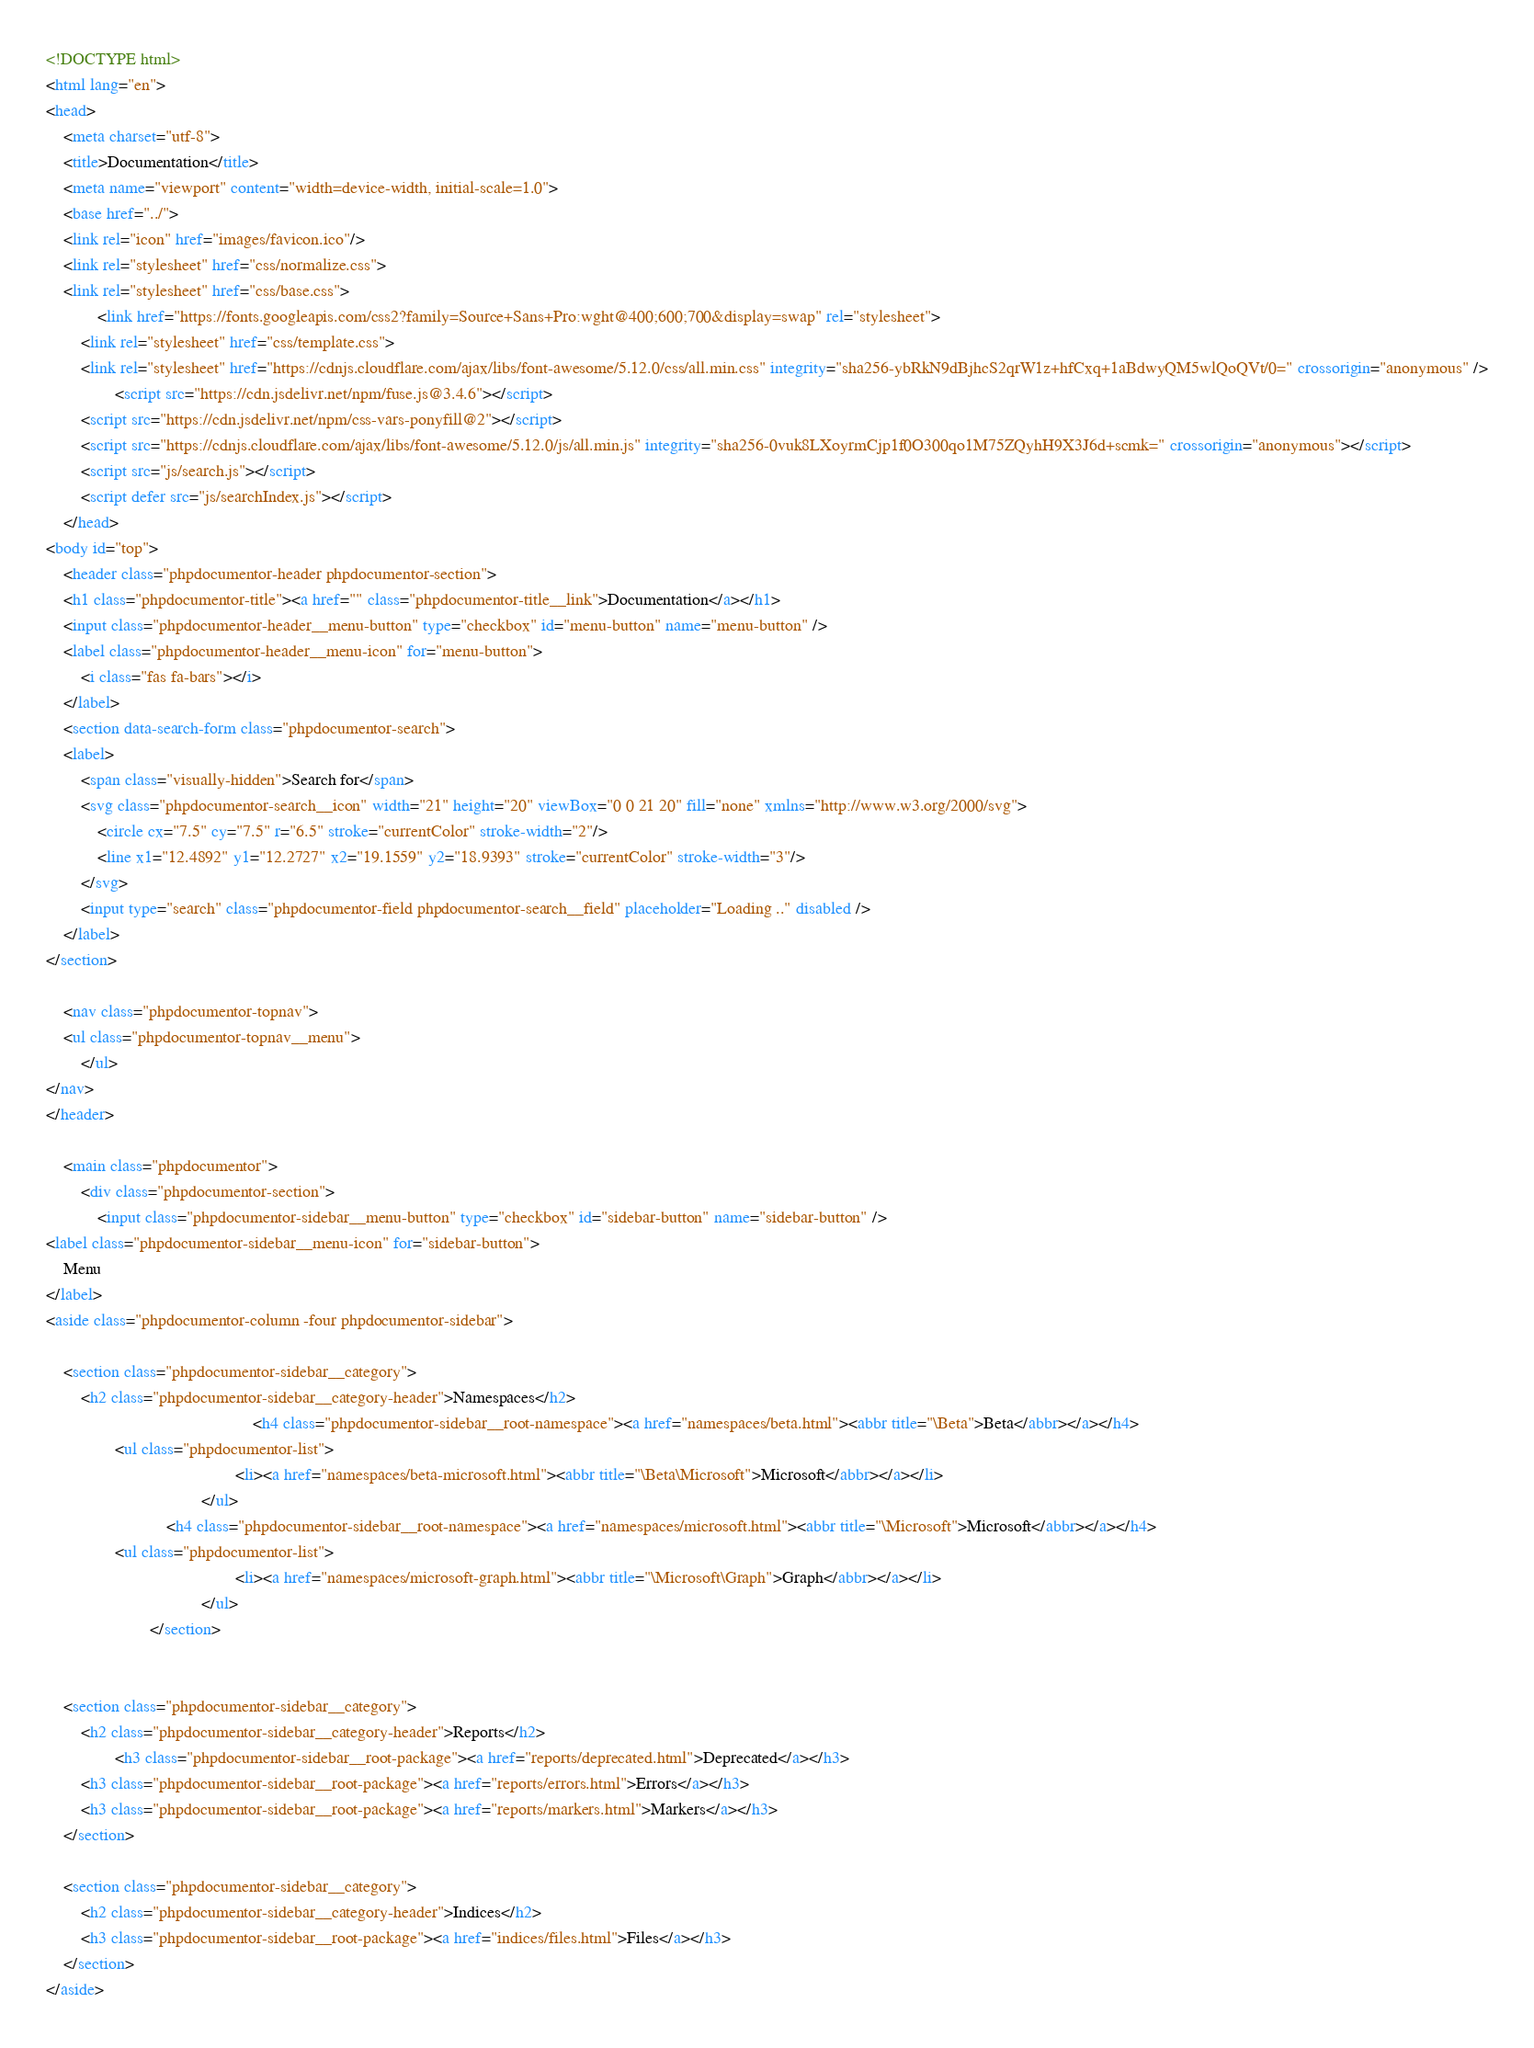<code> <loc_0><loc_0><loc_500><loc_500><_HTML_><!DOCTYPE html>
<html lang="en">
<head>
    <meta charset="utf-8">
    <title>Documentation</title>
    <meta name="viewport" content="width=device-width, initial-scale=1.0">
    <base href="../">
    <link rel="icon" href="images/favicon.ico"/>
    <link rel="stylesheet" href="css/normalize.css">
    <link rel="stylesheet" href="css/base.css">
            <link href="https://fonts.googleapis.com/css2?family=Source+Sans+Pro:wght@400;600;700&display=swap" rel="stylesheet">
        <link rel="stylesheet" href="css/template.css">
        <link rel="stylesheet" href="https://cdnjs.cloudflare.com/ajax/libs/font-awesome/5.12.0/css/all.min.css" integrity="sha256-ybRkN9dBjhcS2qrW1z+hfCxq+1aBdwyQM5wlQoQVt/0=" crossorigin="anonymous" />
                <script src="https://cdn.jsdelivr.net/npm/fuse.js@3.4.6"></script>
        <script src="https://cdn.jsdelivr.net/npm/css-vars-ponyfill@2"></script>
        <script src="https://cdnjs.cloudflare.com/ajax/libs/font-awesome/5.12.0/js/all.min.js" integrity="sha256-0vuk8LXoyrmCjp1f0O300qo1M75ZQyhH9X3J6d+scmk=" crossorigin="anonymous"></script>
        <script src="js/search.js"></script>
        <script defer src="js/searchIndex.js"></script>
    </head>
<body id="top">
    <header class="phpdocumentor-header phpdocumentor-section">
    <h1 class="phpdocumentor-title"><a href="" class="phpdocumentor-title__link">Documentation</a></h1>
    <input class="phpdocumentor-header__menu-button" type="checkbox" id="menu-button" name="menu-button" />
    <label class="phpdocumentor-header__menu-icon" for="menu-button">
        <i class="fas fa-bars"></i>
    </label>
    <section data-search-form class="phpdocumentor-search">
    <label>
        <span class="visually-hidden">Search for</span>
        <svg class="phpdocumentor-search__icon" width="21" height="20" viewBox="0 0 21 20" fill="none" xmlns="http://www.w3.org/2000/svg">
            <circle cx="7.5" cy="7.5" r="6.5" stroke="currentColor" stroke-width="2"/>
            <line x1="12.4892" y1="12.2727" x2="19.1559" y2="18.9393" stroke="currentColor" stroke-width="3"/>
        </svg>
        <input type="search" class="phpdocumentor-field phpdocumentor-search__field" placeholder="Loading .." disabled />
    </label>
</section>

    <nav class="phpdocumentor-topnav">
    <ul class="phpdocumentor-topnav__menu">
        </ul>
</nav>
</header>

    <main class="phpdocumentor">
        <div class="phpdocumentor-section">
            <input class="phpdocumentor-sidebar__menu-button" type="checkbox" id="sidebar-button" name="sidebar-button" />
<label class="phpdocumentor-sidebar__menu-icon" for="sidebar-button">
    Menu
</label>
<aside class="phpdocumentor-column -four phpdocumentor-sidebar">
    
    <section class="phpdocumentor-sidebar__category">
        <h2 class="phpdocumentor-sidebar__category-header">Namespaces</h2>
                                                <h4 class="phpdocumentor-sidebar__root-namespace"><a href="namespaces/beta.html"><abbr title="\Beta">Beta</abbr></a></h4>
                <ul class="phpdocumentor-list">
                                            <li><a href="namespaces/beta-microsoft.html"><abbr title="\Beta\Microsoft">Microsoft</abbr></a></li>
                                    </ul>
                            <h4 class="phpdocumentor-sidebar__root-namespace"><a href="namespaces/microsoft.html"><abbr title="\Microsoft">Microsoft</abbr></a></h4>
                <ul class="phpdocumentor-list">
                                            <li><a href="namespaces/microsoft-graph.html"><abbr title="\Microsoft\Graph">Graph</abbr></a></li>
                                    </ul>
                        </section>

    
    <section class="phpdocumentor-sidebar__category">
        <h2 class="phpdocumentor-sidebar__category-header">Reports</h2>
                <h3 class="phpdocumentor-sidebar__root-package"><a href="reports/deprecated.html">Deprecated</a></h3>
        <h3 class="phpdocumentor-sidebar__root-package"><a href="reports/errors.html">Errors</a></h3>
        <h3 class="phpdocumentor-sidebar__root-package"><a href="reports/markers.html">Markers</a></h3>
    </section>

    <section class="phpdocumentor-sidebar__category">
        <h2 class="phpdocumentor-sidebar__category-header">Indices</h2>
        <h3 class="phpdocumentor-sidebar__root-package"><a href="indices/files.html">Files</a></h3>
    </section>
</aside>
</code> 